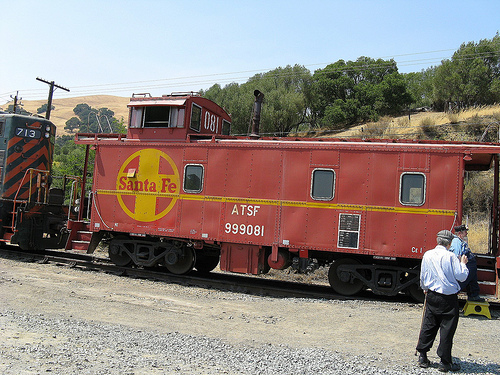<image>
Is there a train behind the person? No. The train is not behind the person. From this viewpoint, the train appears to be positioned elsewhere in the scene. 